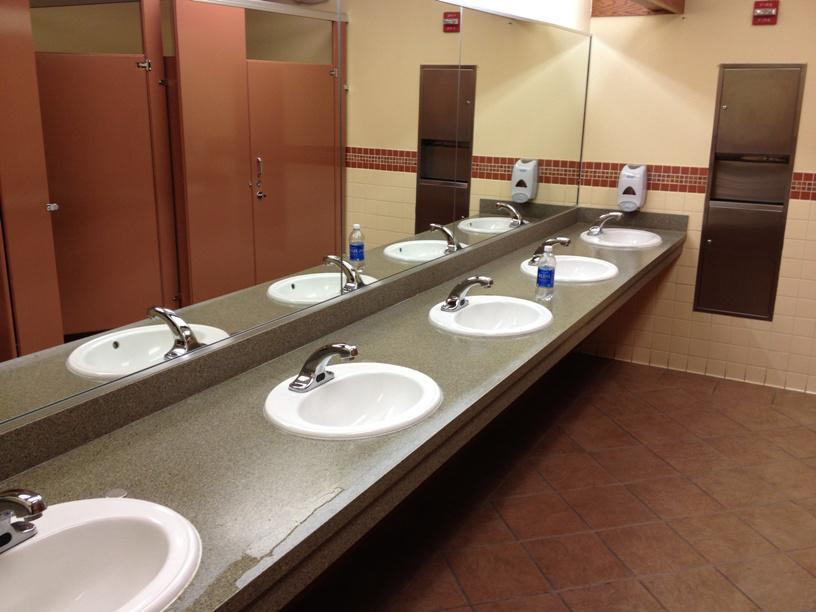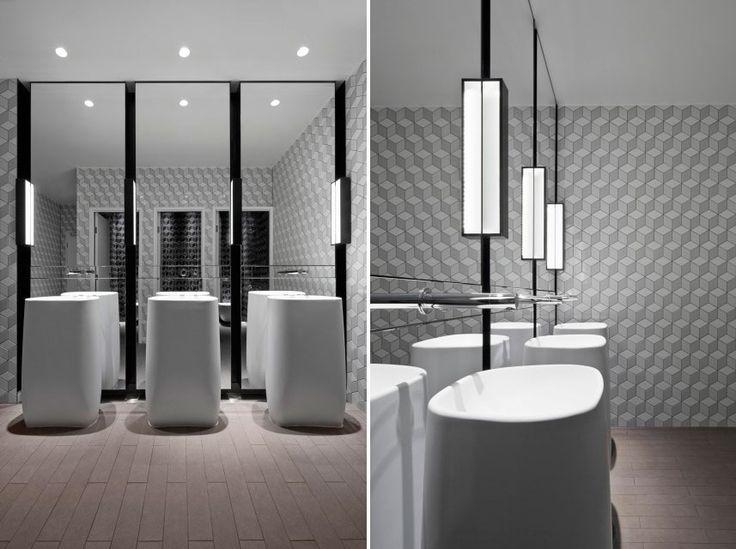The first image is the image on the left, the second image is the image on the right. For the images shown, is this caption "The right image contains at least two sinks." true? Answer yes or no. Yes. The first image is the image on the left, the second image is the image on the right. Examine the images to the left and right. Is the description "In at least one image, a human hand is visible interacting with a soap dispenser" accurate? Answer yes or no. No. 